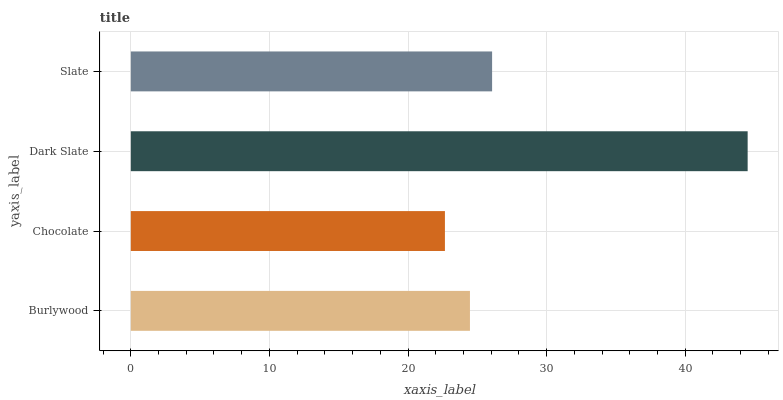Is Chocolate the minimum?
Answer yes or no. Yes. Is Dark Slate the maximum?
Answer yes or no. Yes. Is Dark Slate the minimum?
Answer yes or no. No. Is Chocolate the maximum?
Answer yes or no. No. Is Dark Slate greater than Chocolate?
Answer yes or no. Yes. Is Chocolate less than Dark Slate?
Answer yes or no. Yes. Is Chocolate greater than Dark Slate?
Answer yes or no. No. Is Dark Slate less than Chocolate?
Answer yes or no. No. Is Slate the high median?
Answer yes or no. Yes. Is Burlywood the low median?
Answer yes or no. Yes. Is Dark Slate the high median?
Answer yes or no. No. Is Chocolate the low median?
Answer yes or no. No. 